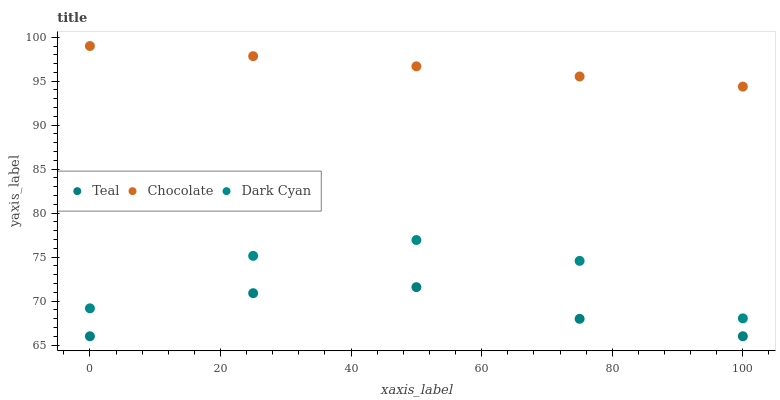Does Teal have the minimum area under the curve?
Answer yes or no. Yes. Does Chocolate have the maximum area under the curve?
Answer yes or no. Yes. Does Chocolate have the minimum area under the curve?
Answer yes or no. No. Does Teal have the maximum area under the curve?
Answer yes or no. No. Is Chocolate the smoothest?
Answer yes or no. Yes. Is Dark Cyan the roughest?
Answer yes or no. Yes. Is Teal the smoothest?
Answer yes or no. No. Is Teal the roughest?
Answer yes or no. No. Does Teal have the lowest value?
Answer yes or no. Yes. Does Chocolate have the lowest value?
Answer yes or no. No. Does Chocolate have the highest value?
Answer yes or no. Yes. Does Teal have the highest value?
Answer yes or no. No. Is Teal less than Chocolate?
Answer yes or no. Yes. Is Dark Cyan greater than Teal?
Answer yes or no. Yes. Does Teal intersect Chocolate?
Answer yes or no. No. 